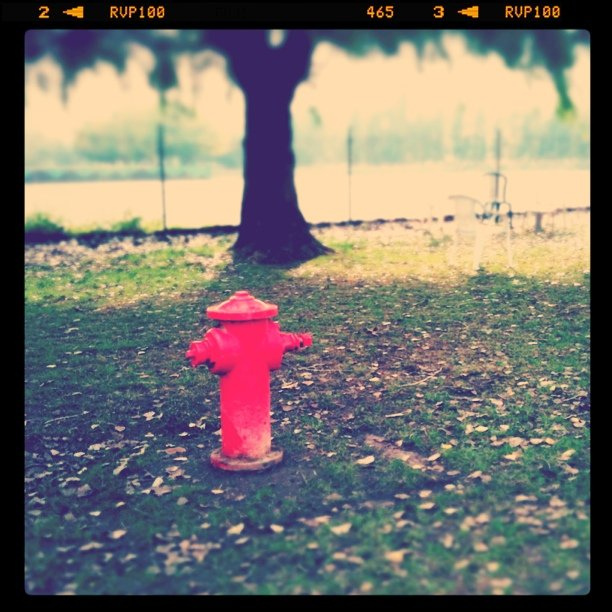Read and extract the text from this image. 2 RVP 100 465 3 RVP100 